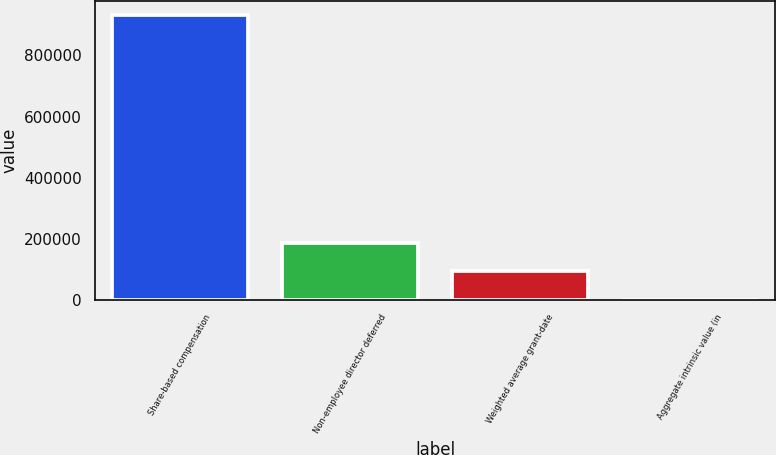<chart> <loc_0><loc_0><loc_500><loc_500><bar_chart><fcel>Share-based compensation<fcel>Non-employee director deferred<fcel>Weighted average grant-date<fcel>Aggregate intrinsic value (in<nl><fcel>932000<fcel>186401<fcel>93201.1<fcel>1.2<nl></chart> 